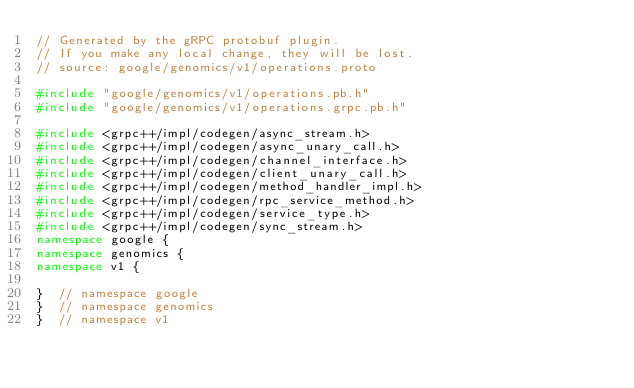<code> <loc_0><loc_0><loc_500><loc_500><_C++_>// Generated by the gRPC protobuf plugin.
// If you make any local change, they will be lost.
// source: google/genomics/v1/operations.proto

#include "google/genomics/v1/operations.pb.h"
#include "google/genomics/v1/operations.grpc.pb.h"

#include <grpc++/impl/codegen/async_stream.h>
#include <grpc++/impl/codegen/async_unary_call.h>
#include <grpc++/impl/codegen/channel_interface.h>
#include <grpc++/impl/codegen/client_unary_call.h>
#include <grpc++/impl/codegen/method_handler_impl.h>
#include <grpc++/impl/codegen/rpc_service_method.h>
#include <grpc++/impl/codegen/service_type.h>
#include <grpc++/impl/codegen/sync_stream.h>
namespace google {
namespace genomics {
namespace v1 {

}  // namespace google
}  // namespace genomics
}  // namespace v1

</code> 